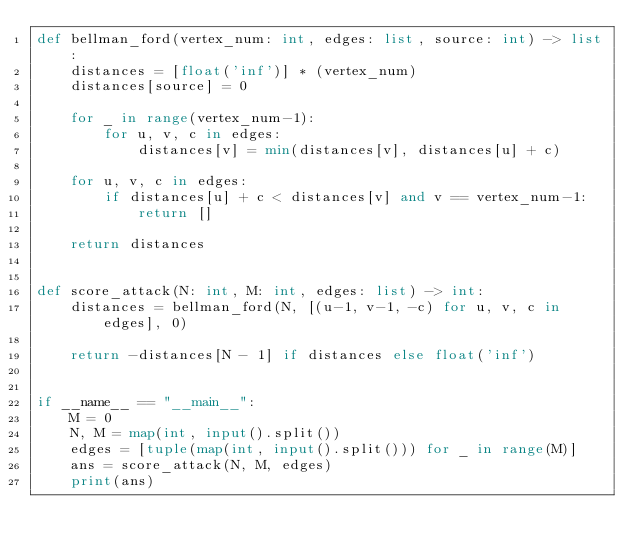<code> <loc_0><loc_0><loc_500><loc_500><_Python_>def bellman_ford(vertex_num: int, edges: list, source: int) -> list:
    distances = [float('inf')] * (vertex_num)
    distances[source] = 0

    for _ in range(vertex_num-1):
        for u, v, c in edges:
            distances[v] = min(distances[v], distances[u] + c)

    for u, v, c in edges:
        if distances[u] + c < distances[v] and v == vertex_num-1:
            return []

    return distances


def score_attack(N: int, M: int, edges: list) -> int:
    distances = bellman_ford(N, [(u-1, v-1, -c) for u, v, c in edges], 0)

    return -distances[N - 1] if distances else float('inf')


if __name__ == "__main__":
    M = 0
    N, M = map(int, input().split())
    edges = [tuple(map(int, input().split())) for _ in range(M)]
    ans = score_attack(N, M, edges)
    print(ans)
</code> 